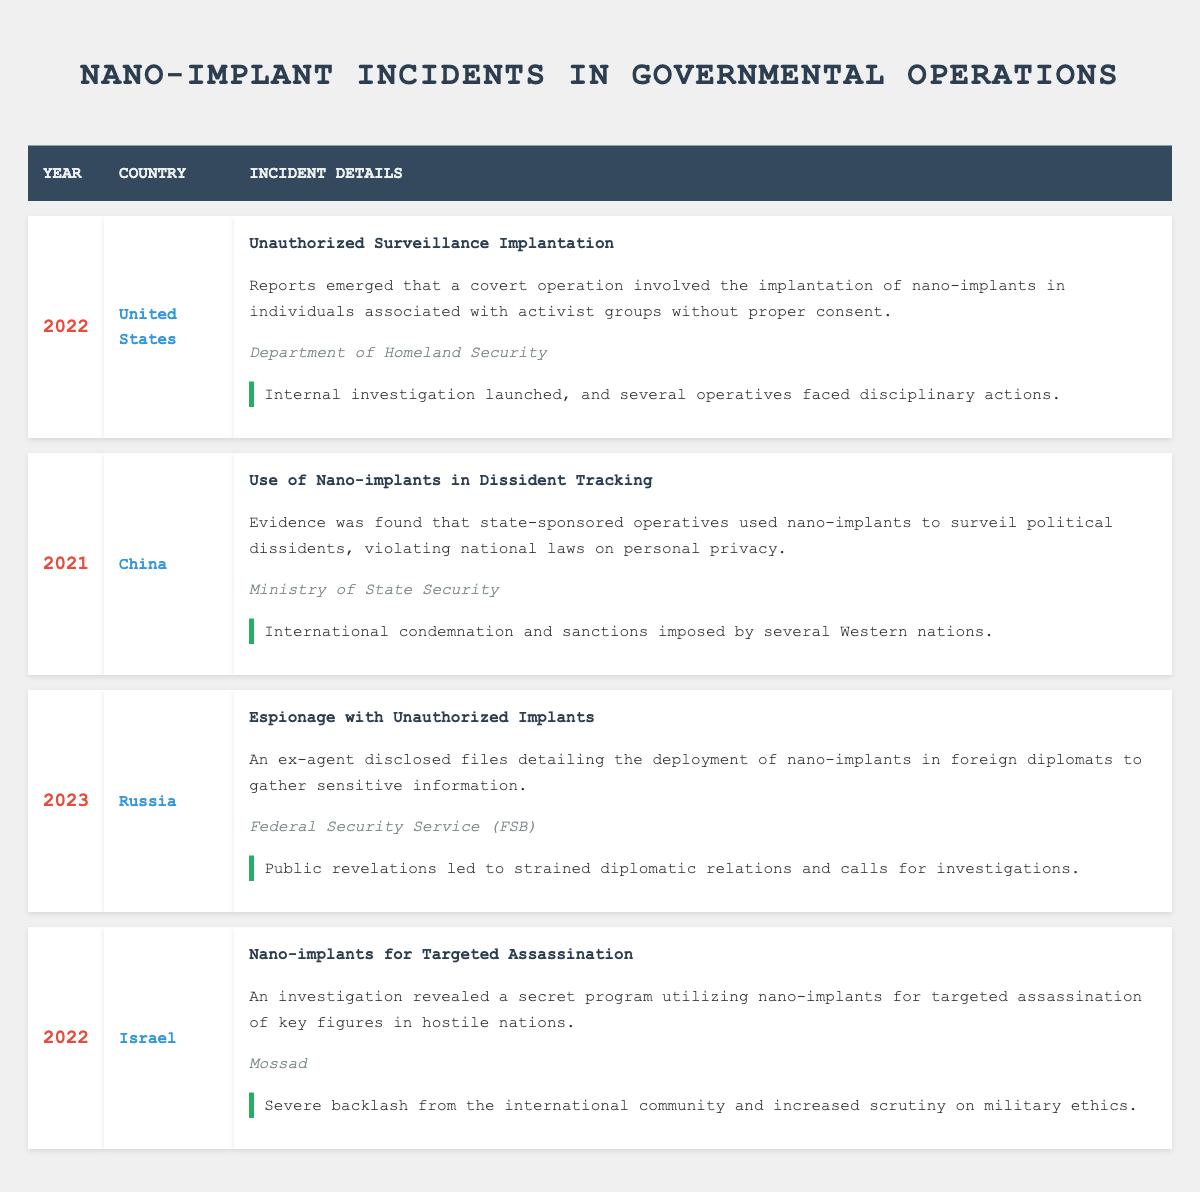What incident occurred in the United States in 2022? In the table, under the United States and the year 2022, the incident listed is "Unauthorized Surveillance Implantation," which involved covert operation with nano-implants being used on individuals associated with activist groups without consent.
Answer: Unauthorized Surveillance Implantation Which government agency was involved in the espionage incident in Russia? Looking at the row about the incident in Russia from 2023, it states that the Federal Security Service (FSB) was the government agency involved in the espionage with unauthorized implants.
Answer: Federal Security Service (FSB) Did any incidents result in international condemnation? By examining the entries in the table, the incident in China in 2021 ("Use of Nano-implants in Dissident Tracking") led to international condemnation and sanctions imposed by several Western nations. Therefore, it can be confirmed that yes, there was an incident that resulted in international condemnation.
Answer: Yes What was the outcome of the incident involving nano-implants for targeted assassination in Israel? Referring to the 2022 incident in Israel, it states that the outcome was severe backlash from the international community and increased scrutiny on military ethics, indicating significant geopolitical repercussions.
Answer: Severe backlash and increased scrutiny on military ethics Which incident involved the use of nano-implants on political dissidents? The incident recorded for China in 2021 is specifically about using nano-implants to surveil political dissidents, thereby making it the relevant entry for that description in the table.
Answer: Use of Nano-implants in Dissident Tracking What is the average year mentioned for these incidents in the table? The years mentioned in the table are 2022, 2021, 2023, and 2022. Adding these together gives 2022 + 2021 + 2023 + 2022 = 8088, and there are 4 incidents. To find the average, divide 8088 by 4, which equals 2022.
Answer: 2022 Was there an internal investigation linked to the unauthorized surveillance incident? Checking the details of the incident in the United States in 2022, the outcome mentions that an internal investigation was launched and several operatives faced disciplinary actions, confirming the presence of an investigation.
Answer: Yes Which country had the incident that led to strained diplomatic relations due to public revelations? The table indicates that the incident in Russia in 2023, involving espionage with unauthorized implants, led to public revelations that strained diplomatic relations, pointing to Russia as the country responsible for this outcome.
Answer: Russia 